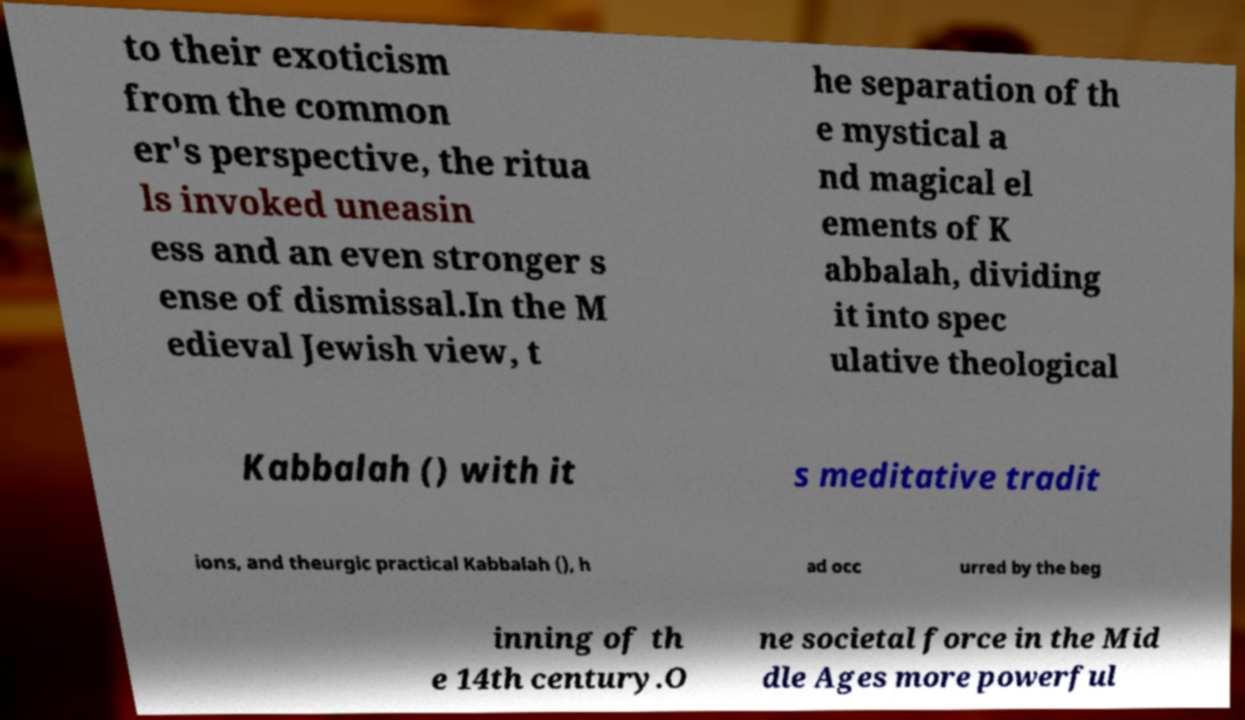Please read and relay the text visible in this image. What does it say? to their exoticism from the common er's perspective, the ritua ls invoked uneasin ess and an even stronger s ense of dismissal.In the M edieval Jewish view, t he separation of th e mystical a nd magical el ements of K abbalah, dividing it into spec ulative theological Kabbalah () with it s meditative tradit ions, and theurgic practical Kabbalah (), h ad occ urred by the beg inning of th e 14th century.O ne societal force in the Mid dle Ages more powerful 